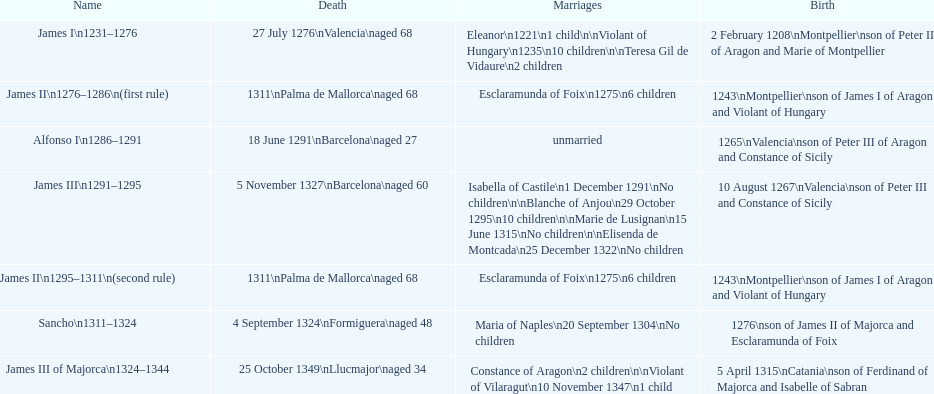Who came to power after the rule of james iii? James II. 